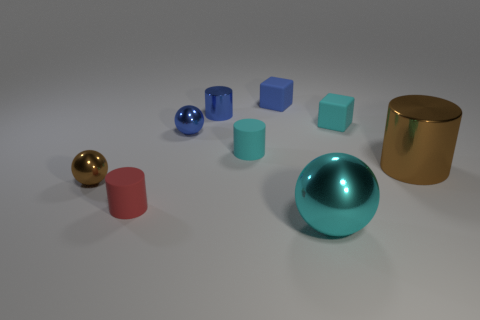Subtract all green cylinders. Subtract all green spheres. How many cylinders are left? 4 Subtract all blocks. How many objects are left? 7 Add 7 large cylinders. How many large cylinders are left? 8 Add 8 big brown objects. How many big brown objects exist? 9 Subtract 0 yellow cylinders. How many objects are left? 9 Subtract all small blue rubber cubes. Subtract all tiny red objects. How many objects are left? 7 